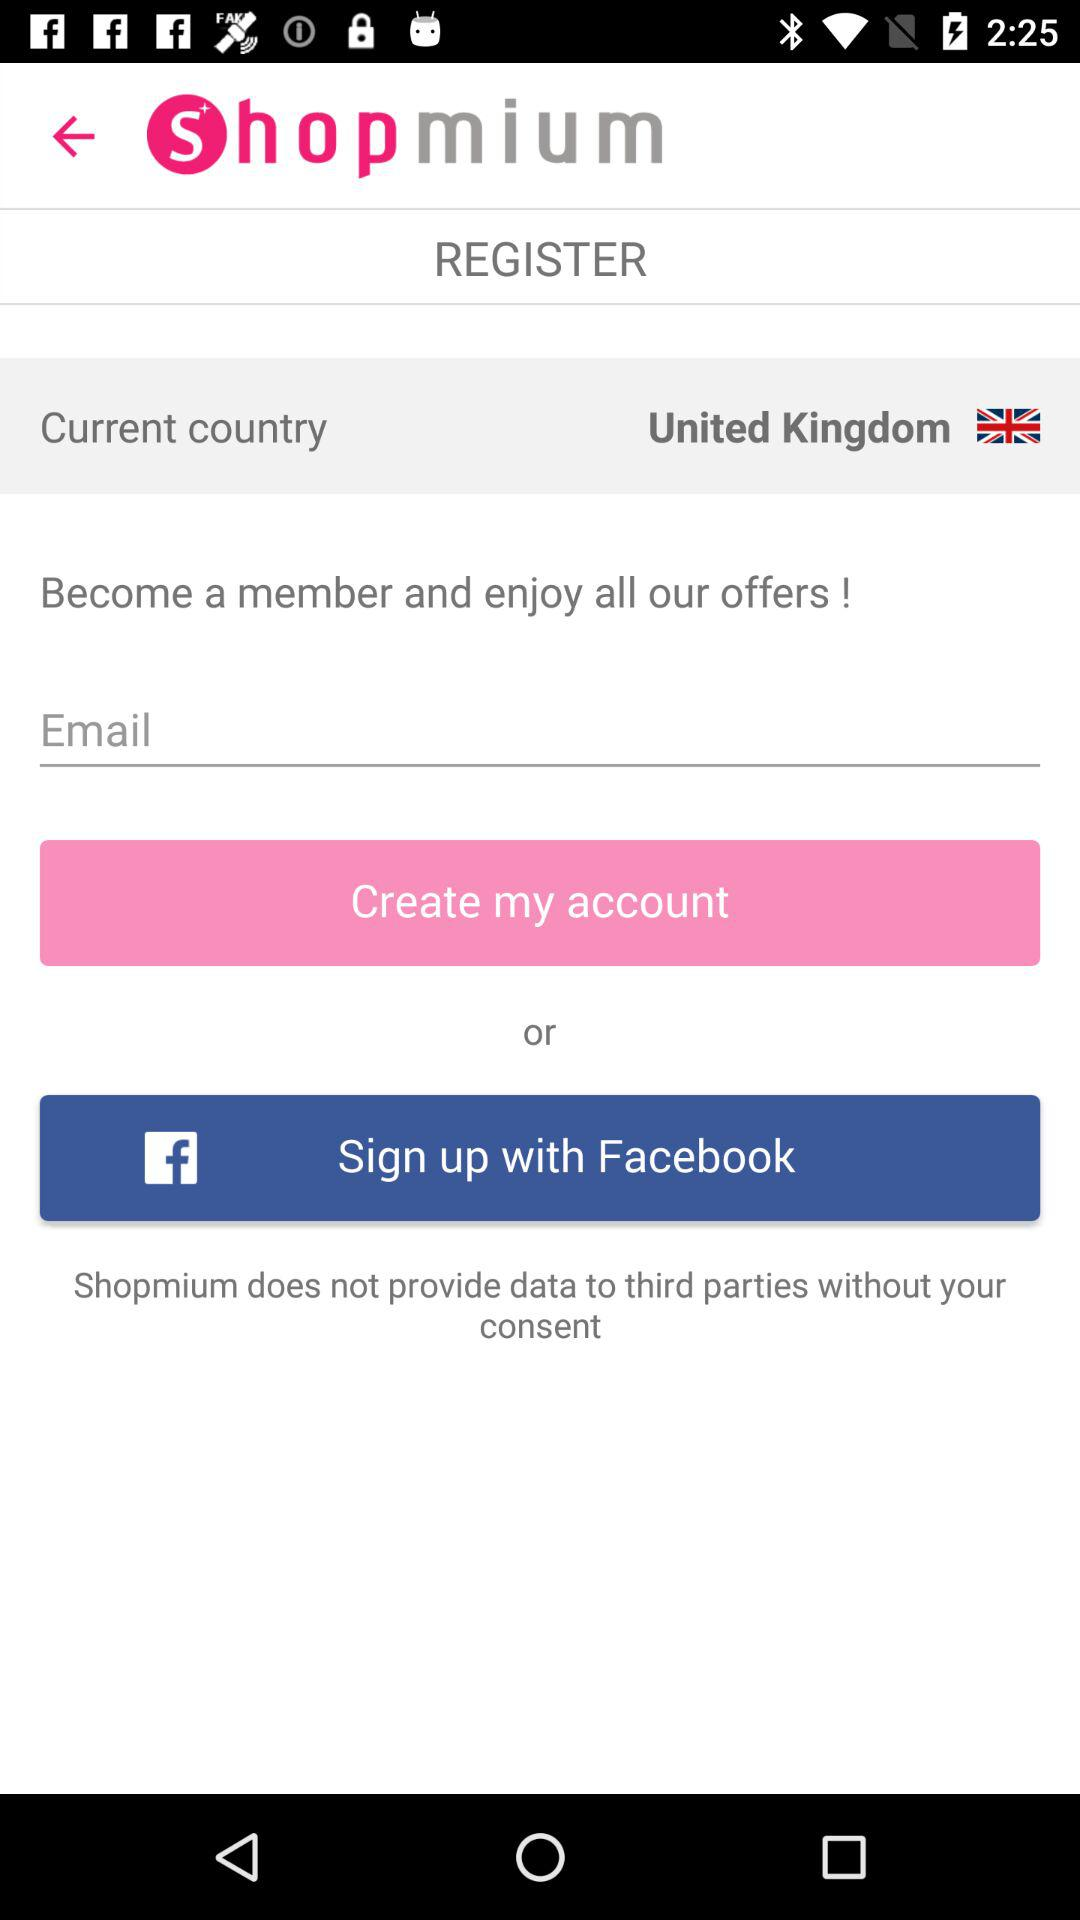What is the application name? The application name is "S h o p m i u m". 